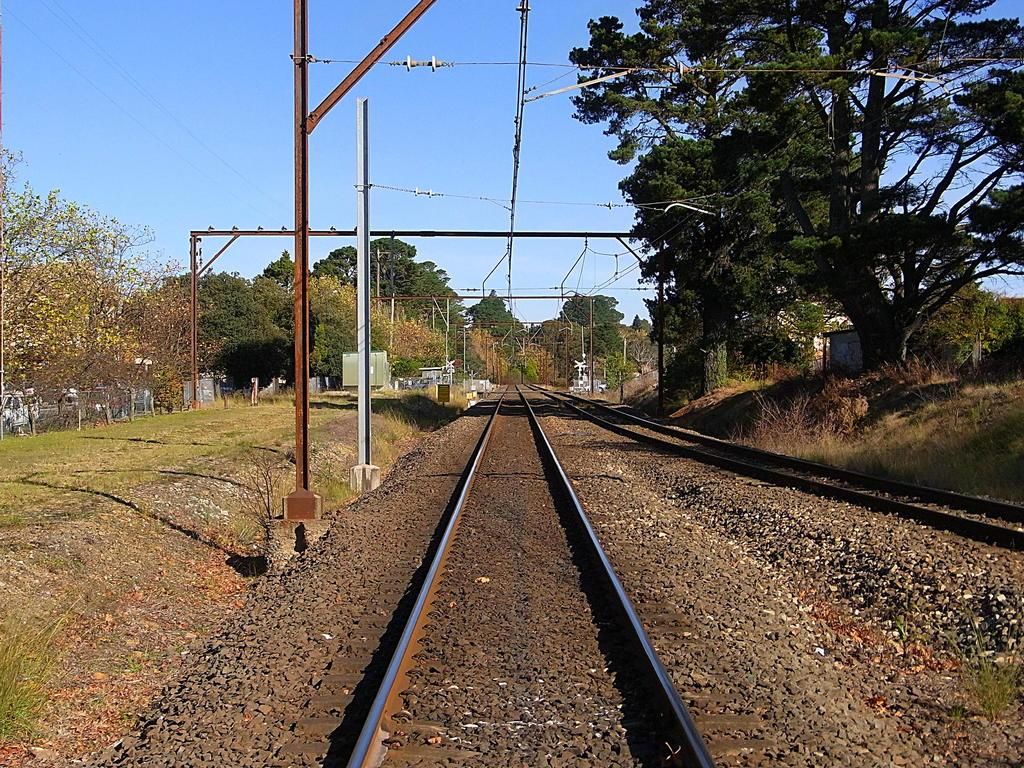What is the main feature of the picture? There is a railway track in the picture. What else can be seen in the picture besides the railway track? There are wires visible in the picture, as well as trees on both the left and right sides. What is the condition of the sky in the picture? The sky is clear and visible at the top of the picture. What type of tax is being discussed in the picture? There is no discussion of tax in the picture; it features a railway track, wires, trees, and a clear sky. Can you see any soap in the picture? There is no soap present in the picture. 